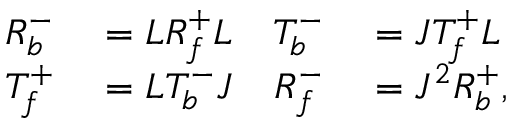<formula> <loc_0><loc_0><loc_500><loc_500>\begin{array} { r l r l } { R _ { b } ^ { - } } & = L R _ { f } ^ { + } L } & { T _ { b } ^ { - } } & = J T _ { f } ^ { + } L } \\ { T _ { f } ^ { + } } & = L T _ { b } ^ { - } J } & { R _ { f } ^ { - } } & = J ^ { 2 } R _ { b } ^ { + } , } \end{array}</formula> 